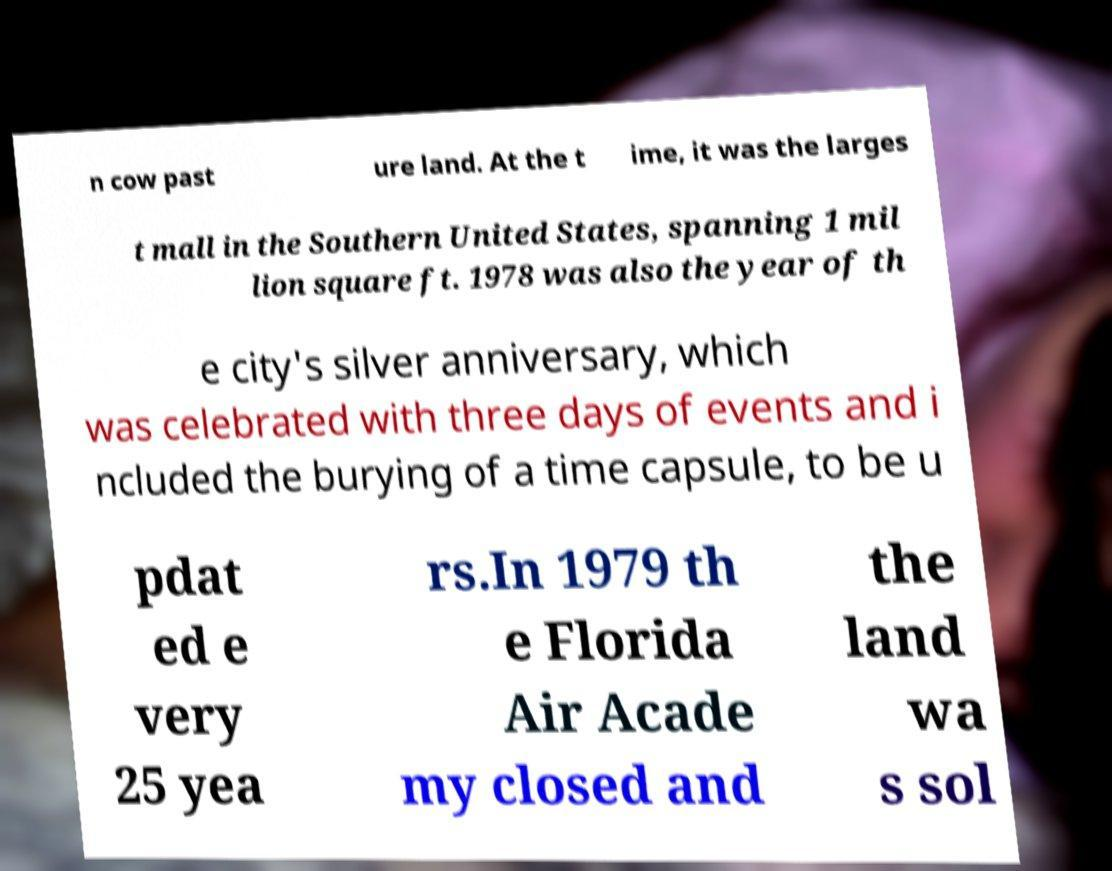Please identify and transcribe the text found in this image. n cow past ure land. At the t ime, it was the larges t mall in the Southern United States, spanning 1 mil lion square ft. 1978 was also the year of th e city's silver anniversary, which was celebrated with three days of events and i ncluded the burying of a time capsule, to be u pdat ed e very 25 yea rs.In 1979 th e Florida Air Acade my closed and the land wa s sol 